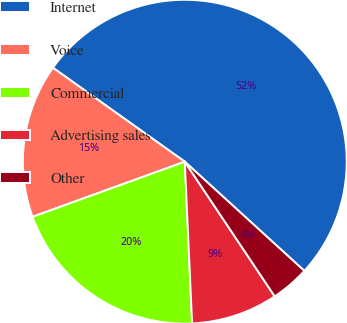Convert chart to OTSL. <chart><loc_0><loc_0><loc_500><loc_500><pie_chart><fcel>Internet<fcel>Voice<fcel>Commercial<fcel>Advertising sales<fcel>Other<nl><fcel>51.92%<fcel>15.38%<fcel>20.19%<fcel>8.65%<fcel>3.85%<nl></chart> 